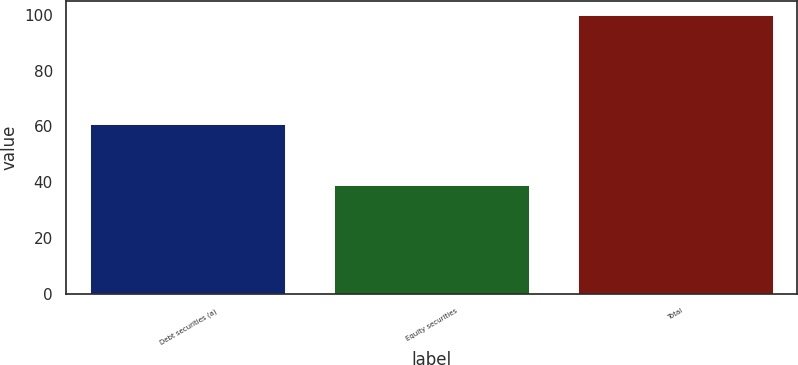Convert chart. <chart><loc_0><loc_0><loc_500><loc_500><bar_chart><fcel>Debt securities (a)<fcel>Equity securities<fcel>Total<nl><fcel>61<fcel>39<fcel>100<nl></chart> 